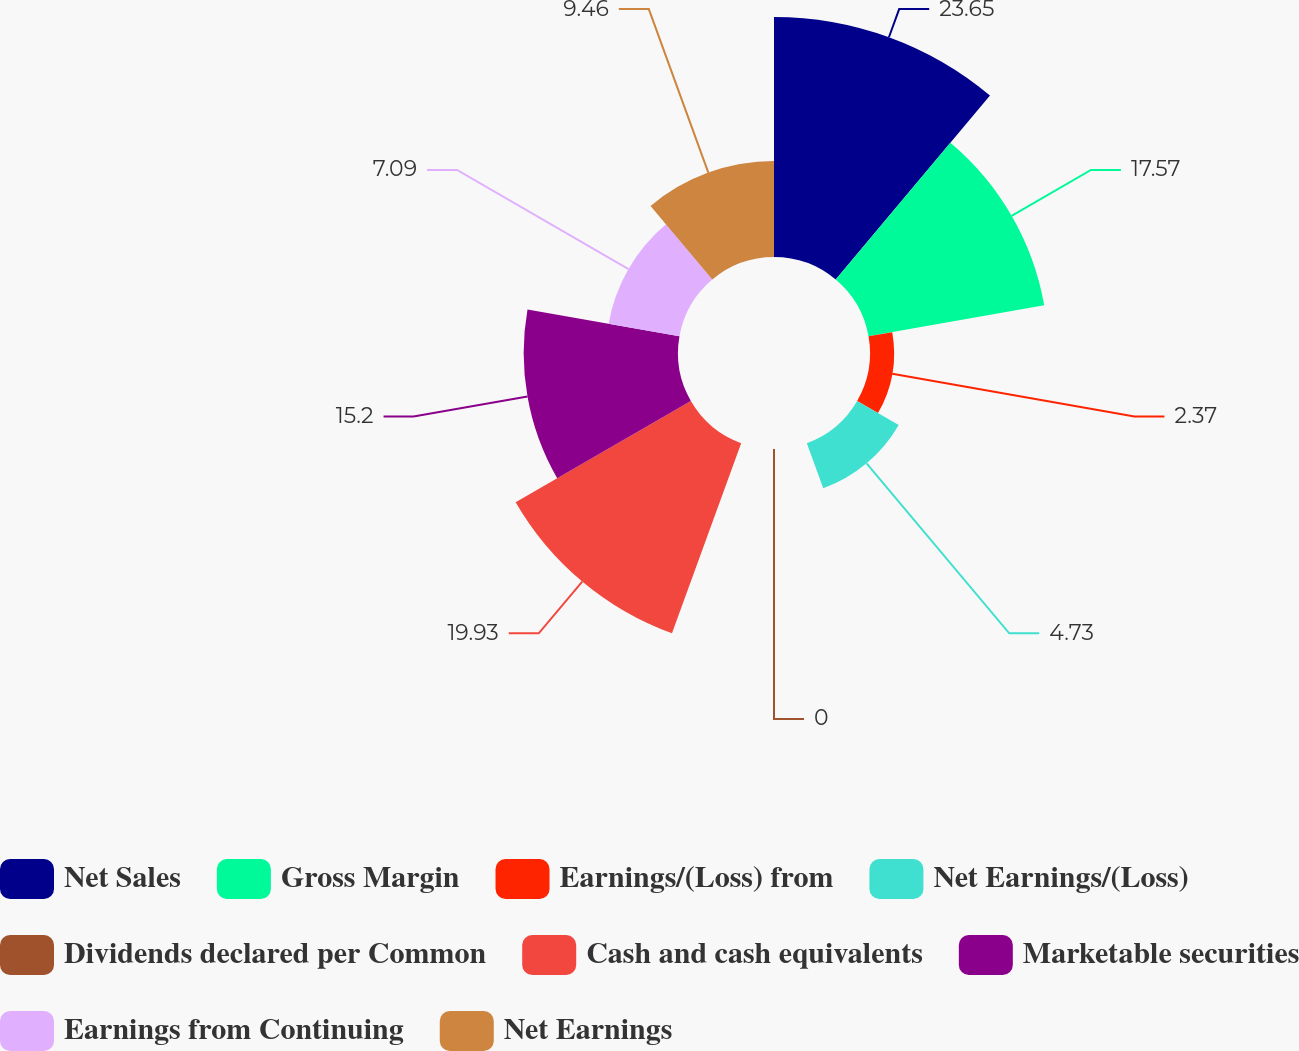Convert chart. <chart><loc_0><loc_0><loc_500><loc_500><pie_chart><fcel>Net Sales<fcel>Gross Margin<fcel>Earnings/(Loss) from<fcel>Net Earnings/(Loss)<fcel>Dividends declared per Common<fcel>Cash and cash equivalents<fcel>Marketable securities<fcel>Earnings from Continuing<fcel>Net Earnings<nl><fcel>23.64%<fcel>17.57%<fcel>2.37%<fcel>4.73%<fcel>0.0%<fcel>19.93%<fcel>15.2%<fcel>7.09%<fcel>9.46%<nl></chart> 